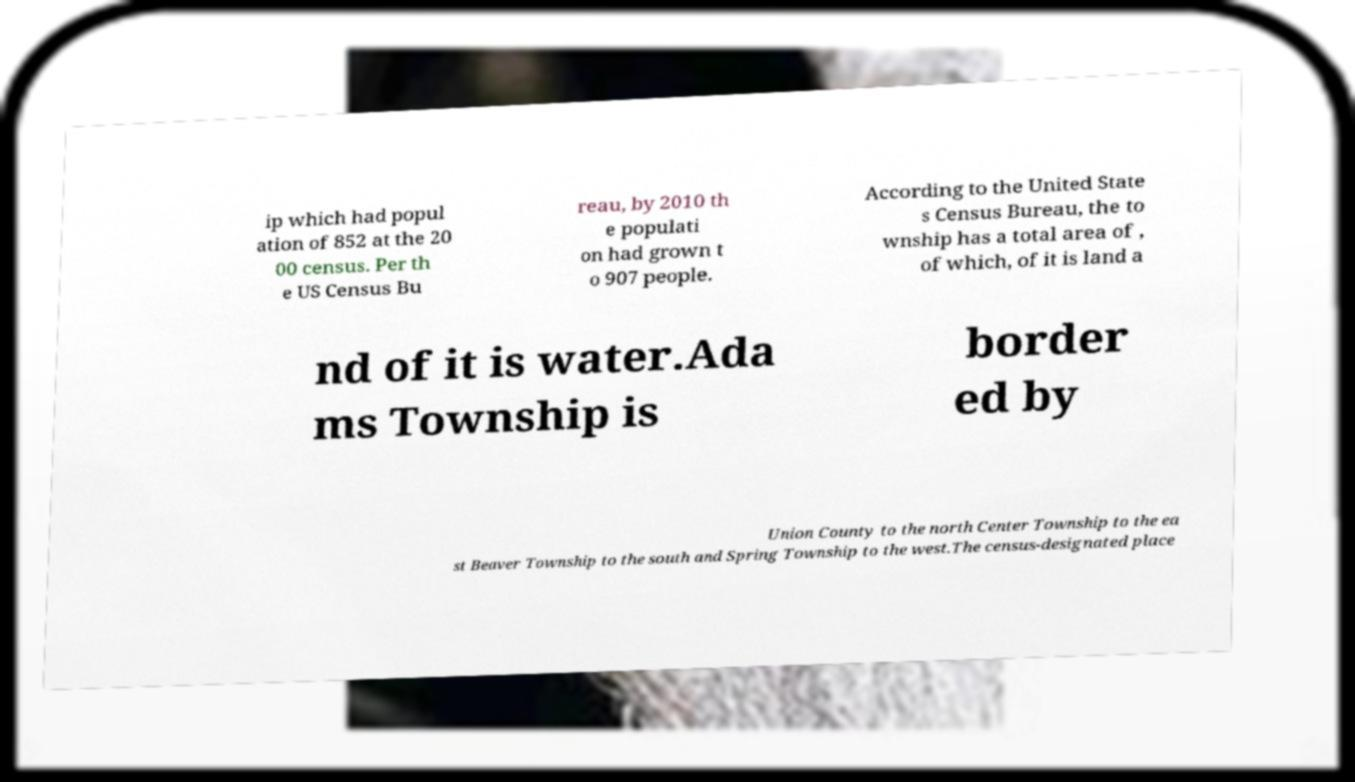There's text embedded in this image that I need extracted. Can you transcribe it verbatim? ip which had popul ation of 852 at the 20 00 census. Per th e US Census Bu reau, by 2010 th e populati on had grown t o 907 people. According to the United State s Census Bureau, the to wnship has a total area of , of which, of it is land a nd of it is water.Ada ms Township is border ed by Union County to the north Center Township to the ea st Beaver Township to the south and Spring Township to the west.The census-designated place 